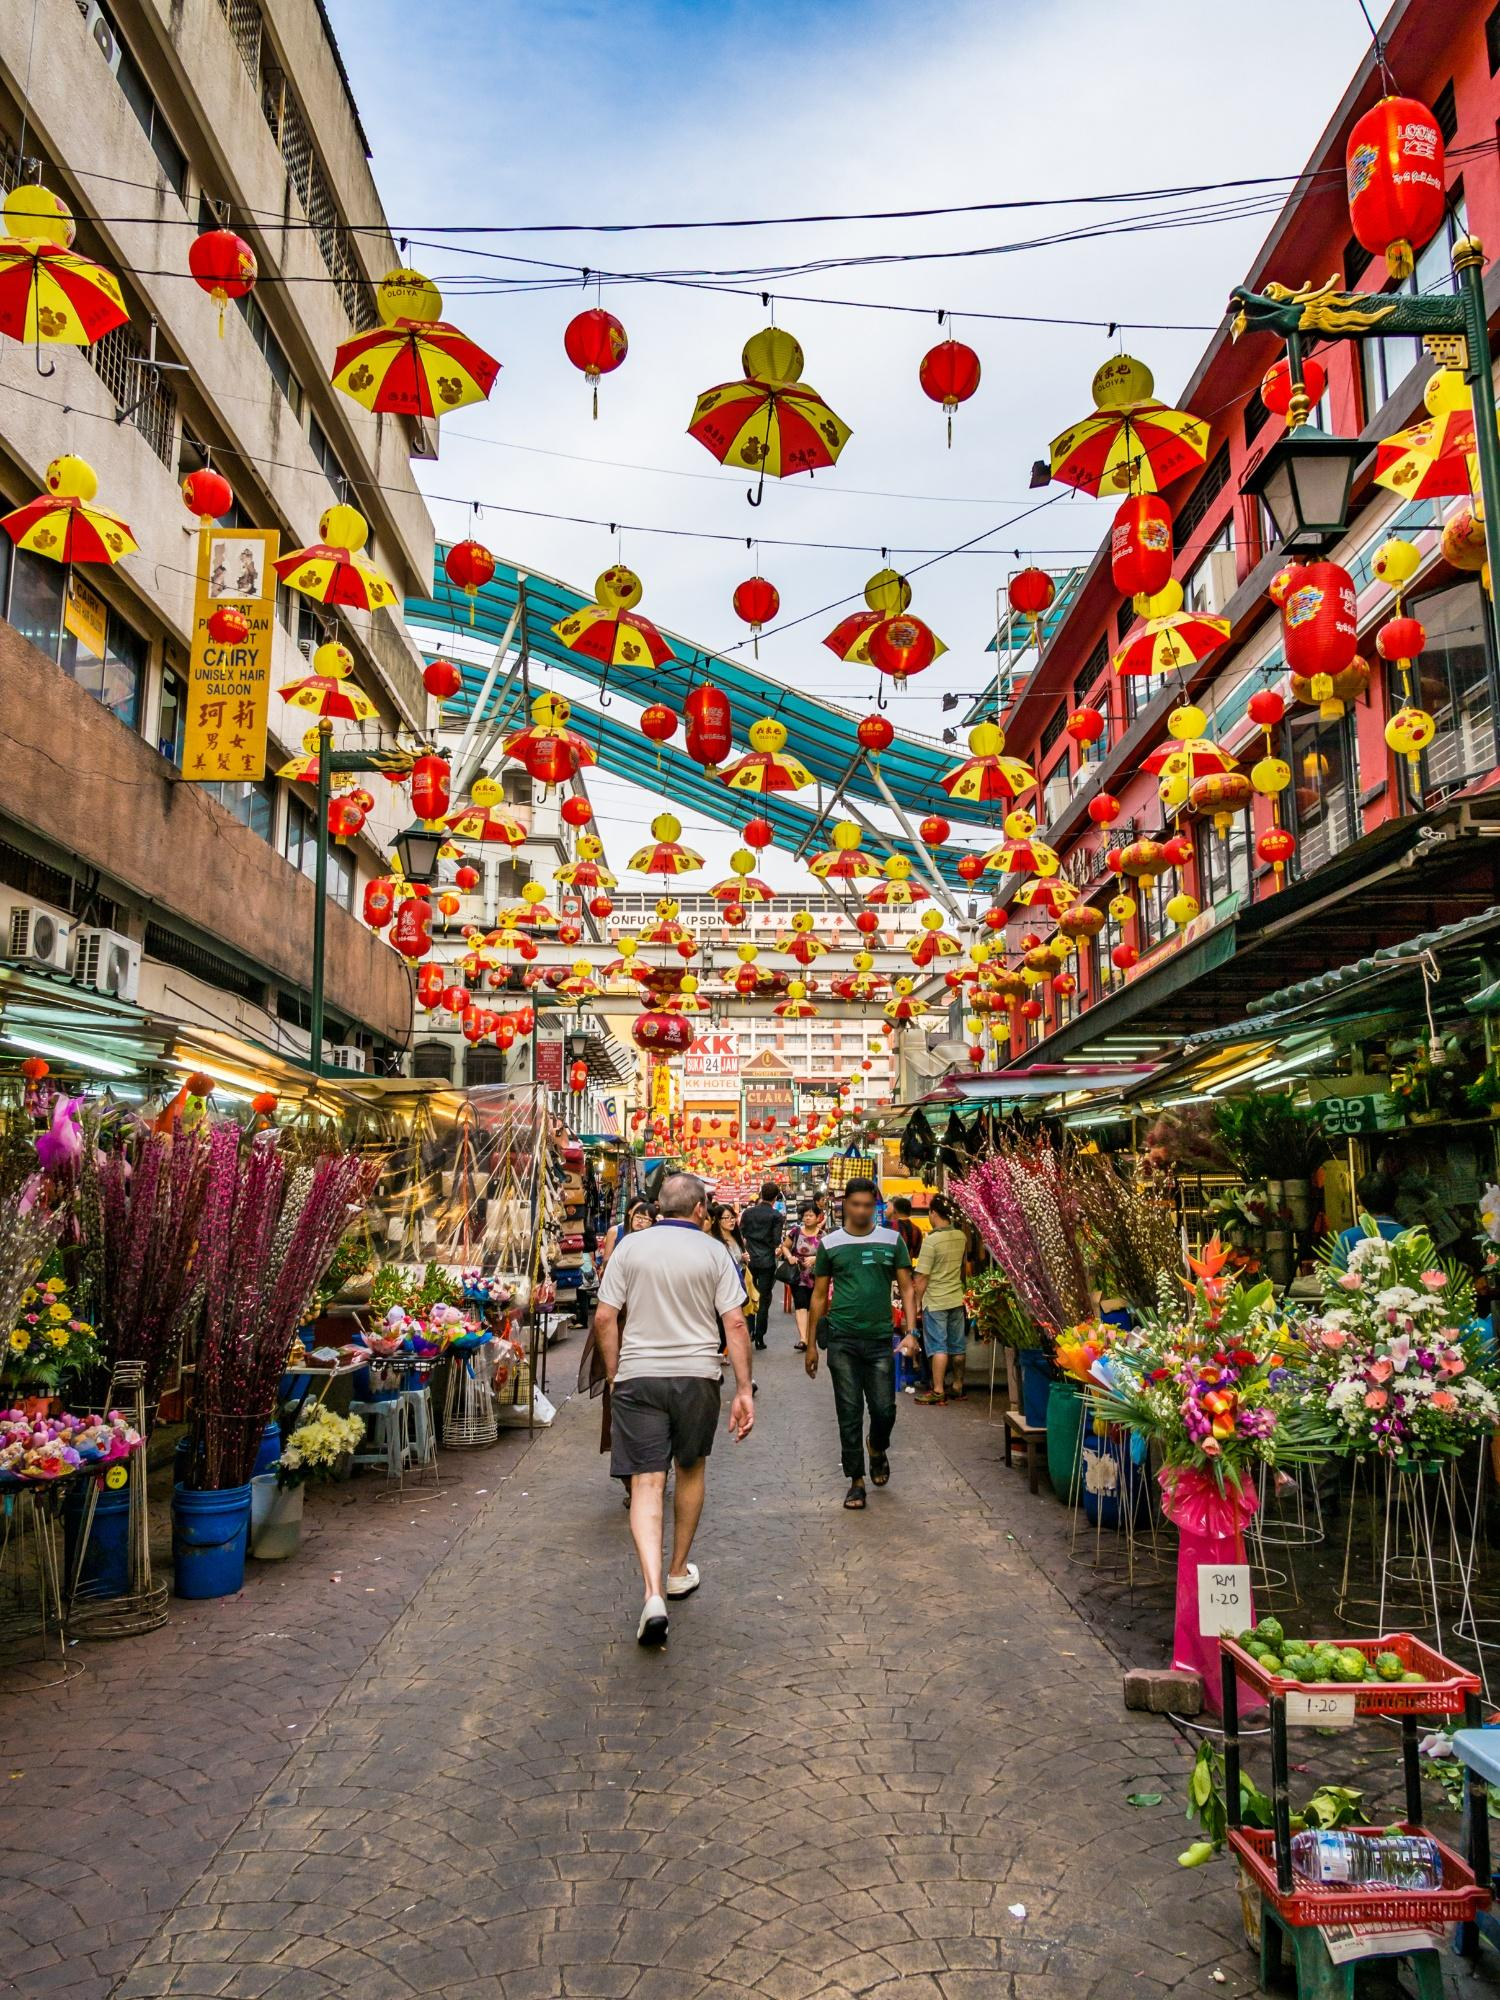Describe the cultural elements visible in this image. This image prominently displays various cultural elements reflecting both Thai and Chinese influences. The red and yellow lanterns strung above the street are quintessential symbols in Chinese culture, often associated with festivals, celebrations, and good fortune. These lanterns match the color scheme of the traditional Chinese New Year decorations, emphasizing themes of prosperity and happiness.

Adding to the festive atmosphere, the umbrellas hanging from wires add a creative flair, possibly to provide shade or simply to enhance the visual appeal. The signs on the buildings feature both Thai and Chinese writing, highlighting the multicultural blend of Bangkok's Chinatown. Moreover, the vibrant flower stalls lining the street could signify the importance of flowers in local rituals and everyday commerce, showcasing the area's commercial vibrancy and cultural richness. 